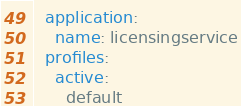Convert code to text. <code><loc_0><loc_0><loc_500><loc_500><_YAML_>  application:
    name: licensingservice
  profiles:
    active:
      default
</code> 